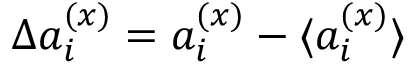<formula> <loc_0><loc_0><loc_500><loc_500>\Delta a _ { i } ^ { ( x ) } = a _ { i } ^ { ( x ) } - \langle { a _ { i } ^ { ( x ) } } \rangle</formula> 